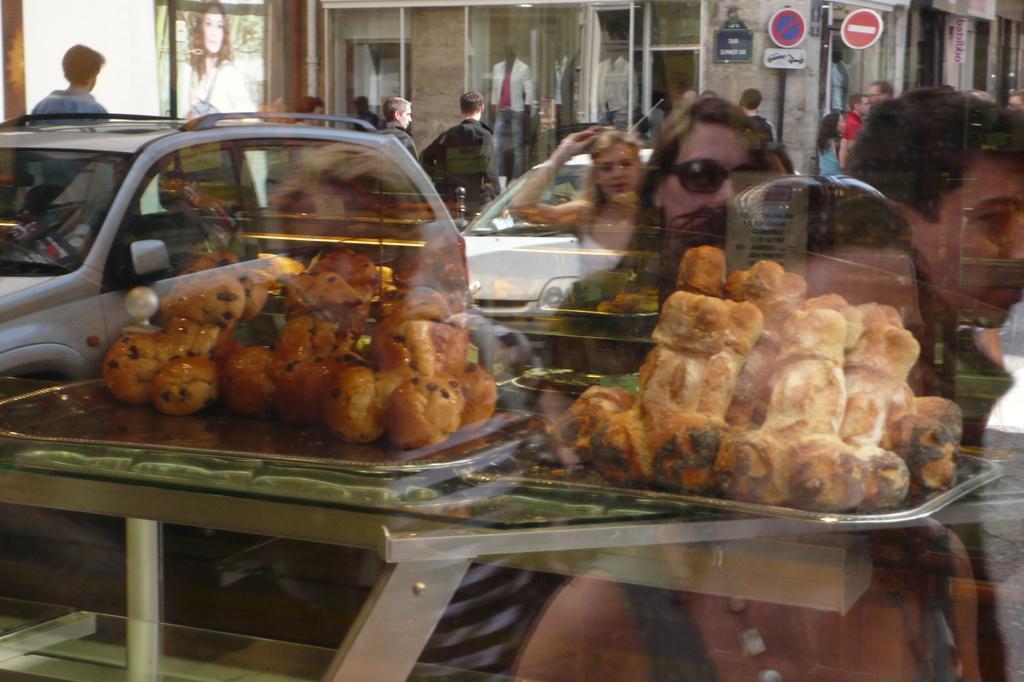Please provide a concise description of this image. These are the food items, which are placed on the trays. This looks like a glass door. I can see the reflection of the vehicles and groups of people standing. These are the sign boards attached to the poles. I can see a mannequin with the clothes. This looks like a poster. 